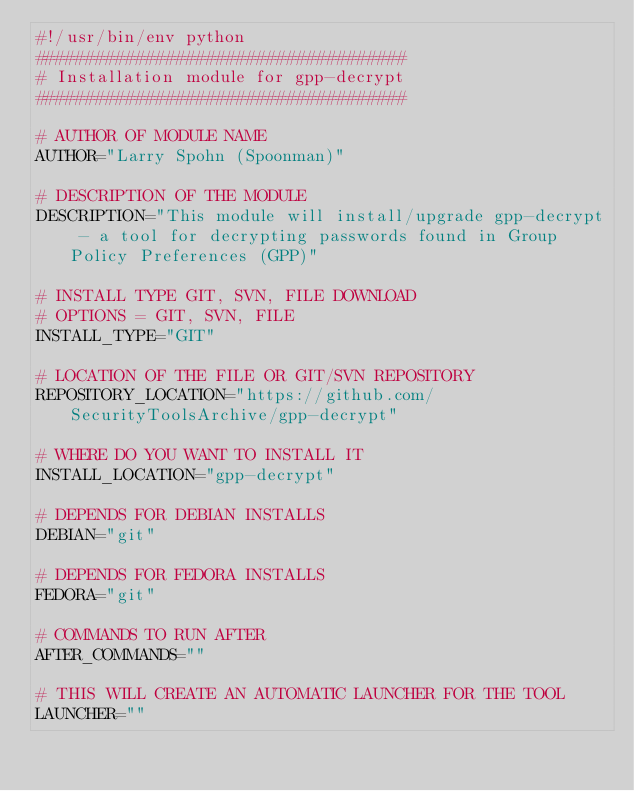Convert code to text. <code><loc_0><loc_0><loc_500><loc_500><_Python_>#!/usr/bin/env python
#####################################
# Installation module for gpp-decrypt
#####################################

# AUTHOR OF MODULE NAME
AUTHOR="Larry Spohn (Spoonman)"

# DESCRIPTION OF THE MODULE
DESCRIPTION="This module will install/upgrade gpp-decrypt - a tool for decrypting passwords found in Group Policy Preferences (GPP)"

# INSTALL TYPE GIT, SVN, FILE DOWNLOAD
# OPTIONS = GIT, SVN, FILE
INSTALL_TYPE="GIT"

# LOCATION OF THE FILE OR GIT/SVN REPOSITORY
REPOSITORY_LOCATION="https://github.com/SecurityToolsArchive/gpp-decrypt"

# WHERE DO YOU WANT TO INSTALL IT
INSTALL_LOCATION="gpp-decrypt"

# DEPENDS FOR DEBIAN INSTALLS
DEBIAN="git"

# DEPENDS FOR FEDORA INSTALLS
FEDORA="git"

# COMMANDS TO RUN AFTER
AFTER_COMMANDS=""

# THIS WILL CREATE AN AUTOMATIC LAUNCHER FOR THE TOOL
LAUNCHER=""
</code> 